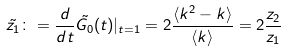Convert formula to latex. <formula><loc_0><loc_0><loc_500><loc_500>\tilde { z _ { 1 } } \colon = \frac { d } { d t } \tilde { G _ { 0 } } ( t ) | _ { t = 1 } = 2 \frac { \langle k ^ { 2 } - k \rangle } { \langle k \rangle } = 2 \frac { z _ { 2 } } { z _ { 1 } }</formula> 